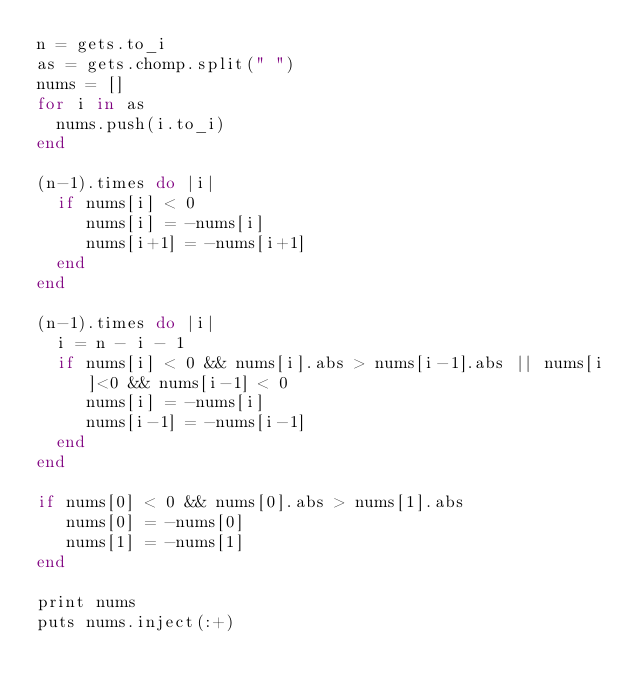Convert code to text. <code><loc_0><loc_0><loc_500><loc_500><_Ruby_>n = gets.to_i
as = gets.chomp.split(" ")
nums = []
for i in as
  nums.push(i.to_i)
end

(n-1).times do |i|
  if nums[i] < 0
     nums[i] = -nums[i]
     nums[i+1] = -nums[i+1]
  end
end

(n-1).times do |i|
  i = n - i - 1
  if nums[i] < 0 && nums[i].abs > nums[i-1].abs || nums[i]<0 && nums[i-1] < 0
     nums[i] = -nums[i]
     nums[i-1] = -nums[i-1]
  end
end

if nums[0] < 0 && nums[0].abs > nums[1].abs
   nums[0] = -nums[0]
   nums[1] = -nums[1]
end

print nums
puts nums.inject(:+)</code> 